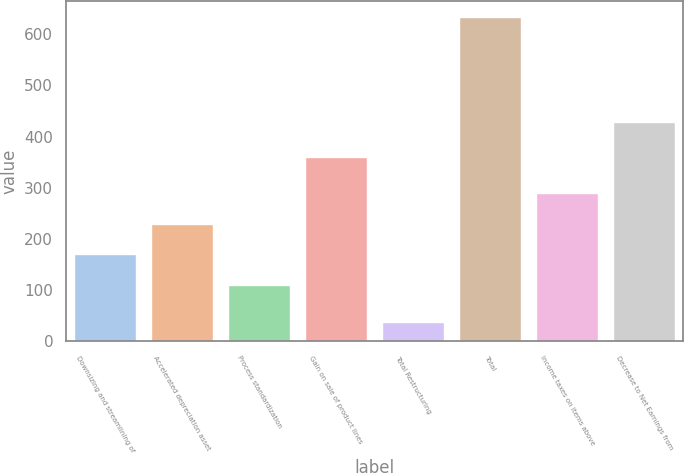Convert chart. <chart><loc_0><loc_0><loc_500><loc_500><bar_chart><fcel>Downsizing and streamlining of<fcel>Accelerated depreciation asset<fcel>Process standardization<fcel>Gain on sale of product lines<fcel>Total Restructuring<fcel>Total<fcel>Income taxes on items above<fcel>Decrease to Net Earnings from<nl><fcel>169.6<fcel>229.2<fcel>110<fcel>360<fcel>37<fcel>633<fcel>288.8<fcel>428<nl></chart> 